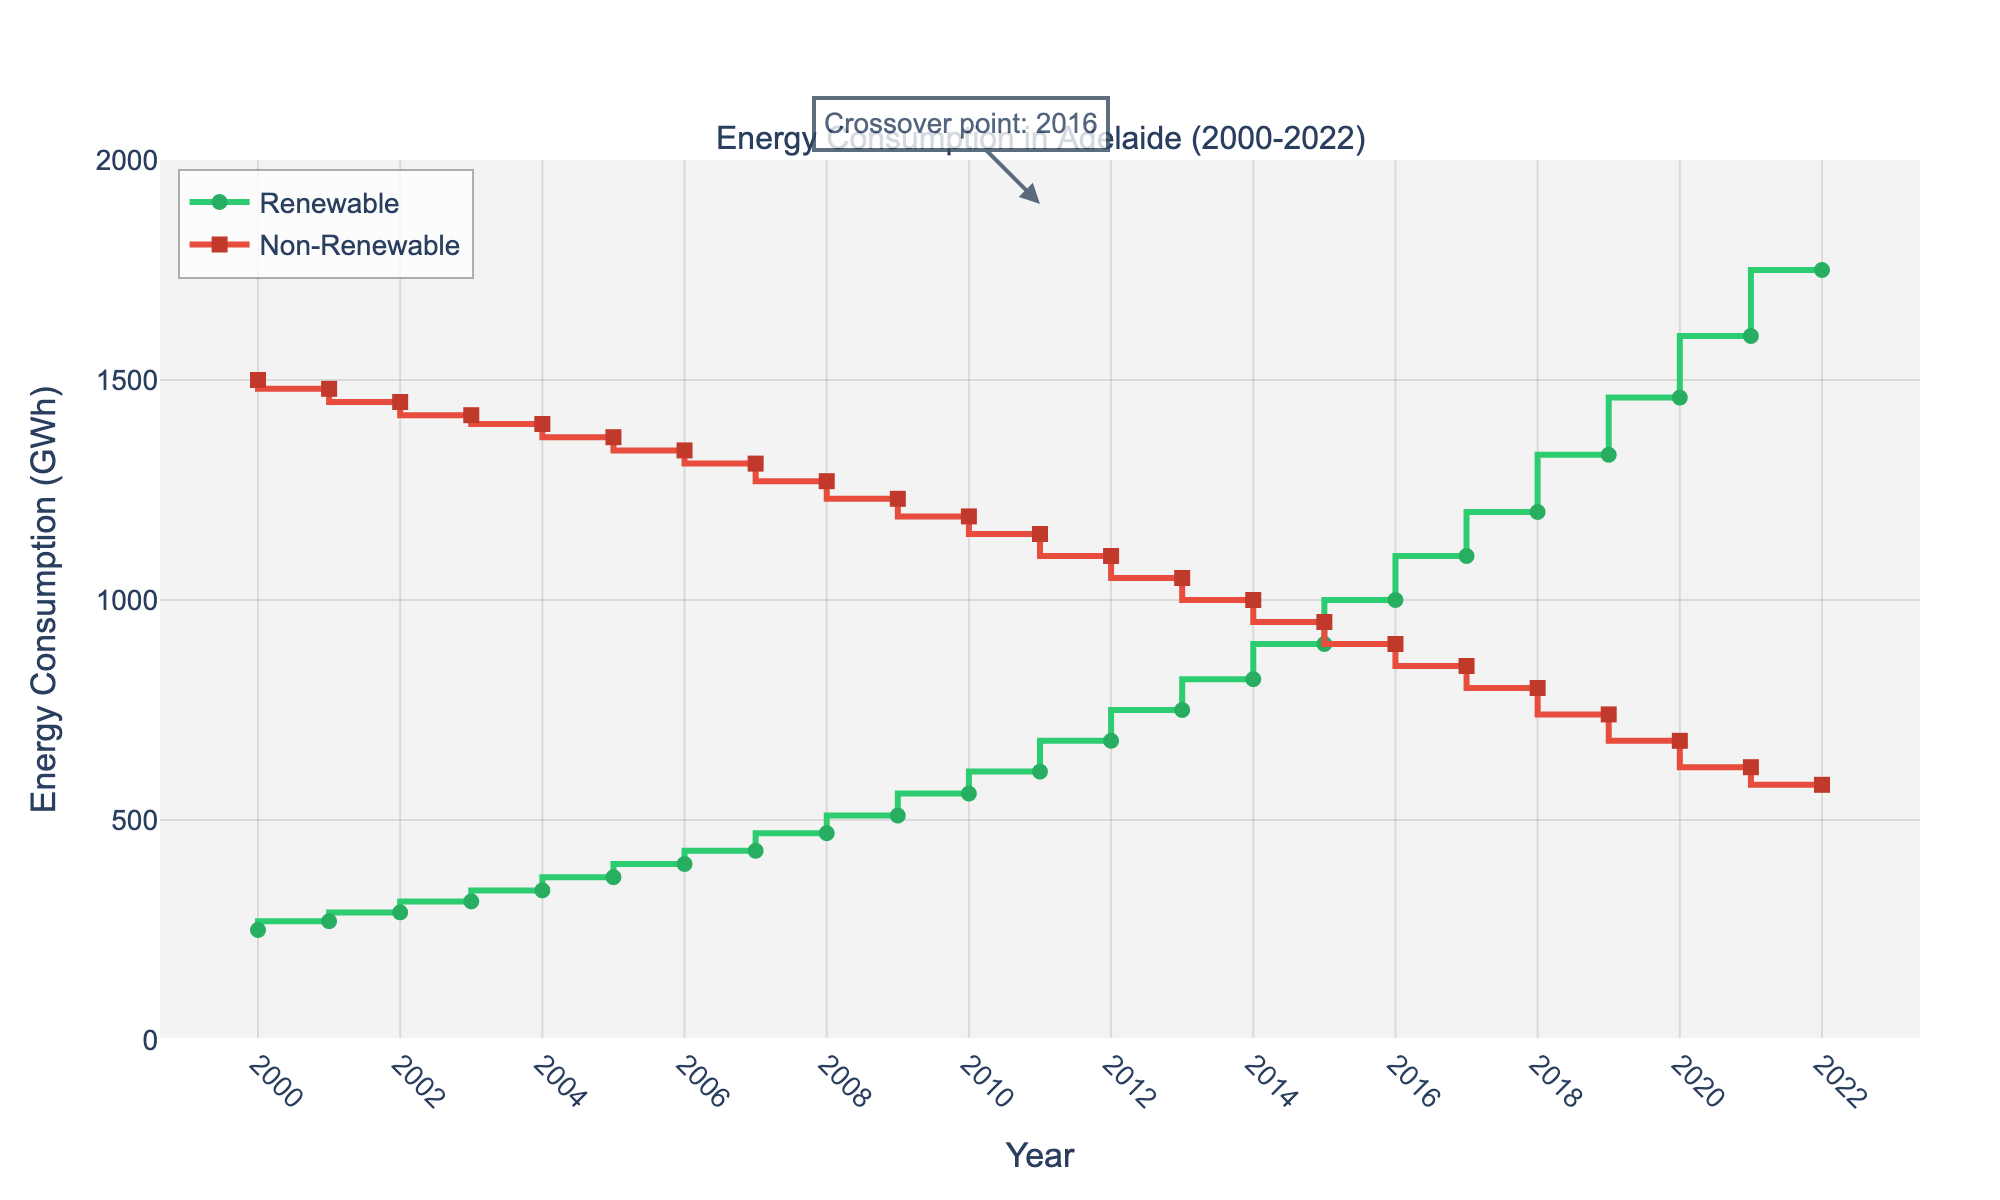What is the title of the plot? The title of the plot is typically placed at the top and provides an overview of what the figure represents. In this case, it reads "Energy Consumption in Adelaide (2000-2022)."
Answer: Energy Consumption in Adelaide (2000-2022) What color is used to represent renewable energy consumption? The color used for renewable energy can be identified by looking at the legend or the line. The renewable energy line is green.
Answer: Green How many years are displayed in the plot? The x-axis shows the range of years which starts from 2000 and goes until 2022. The number of years is calculated as 2022 - 2000 + 1.
Answer: 23 In which year did renewable energy consumption exceed 1000 GWh? By looking at the green line representing renewable energy, it crosses the 1000 GWh mark in the year 2016.
Answer: 2016 What is the general trend in non-renewable energy consumption from 2000 to 2022? Observing the red line representing non-renewable energy, it shows a declining trend from 2000 (1500 GWh) to 2022 (580 GWh).
Answer: Decreasing What's the difference in renewable energy consumption between 2019 and 2022? Renewable energy consumption in 2019 is 1330 GWh and in 2022 it is 1750 GWh. The difference is calculated as 1750 - 1330.
Answer: 420 GWh Which year had the highest non-renewable energy consumption? The peak consumption for non-renewable energy can be seen at the starting point in 2000, which is 1500 GWh.
Answer: 2000 Compare the total energy consumption (renewable + non-renewable) in 2000 and 2022. Which year had higher total consumption, and by how much? Total energy consumption for 2000 is 250 (renewable) + 1500 (non-renewable) = 1750 GWh. For 2022, it is 1750 (renewable) + 580 (non-renewable) = 2330 GWh. 2022 had higher consumption by 2330 - 1750.
Answer: 2022, by 580 GWh At what year do renewable and non-renewable energy lines crossover? The crossover point is annotated in the plot itself, and it shows that the lines cross over in 2016.
Answer: 2016 